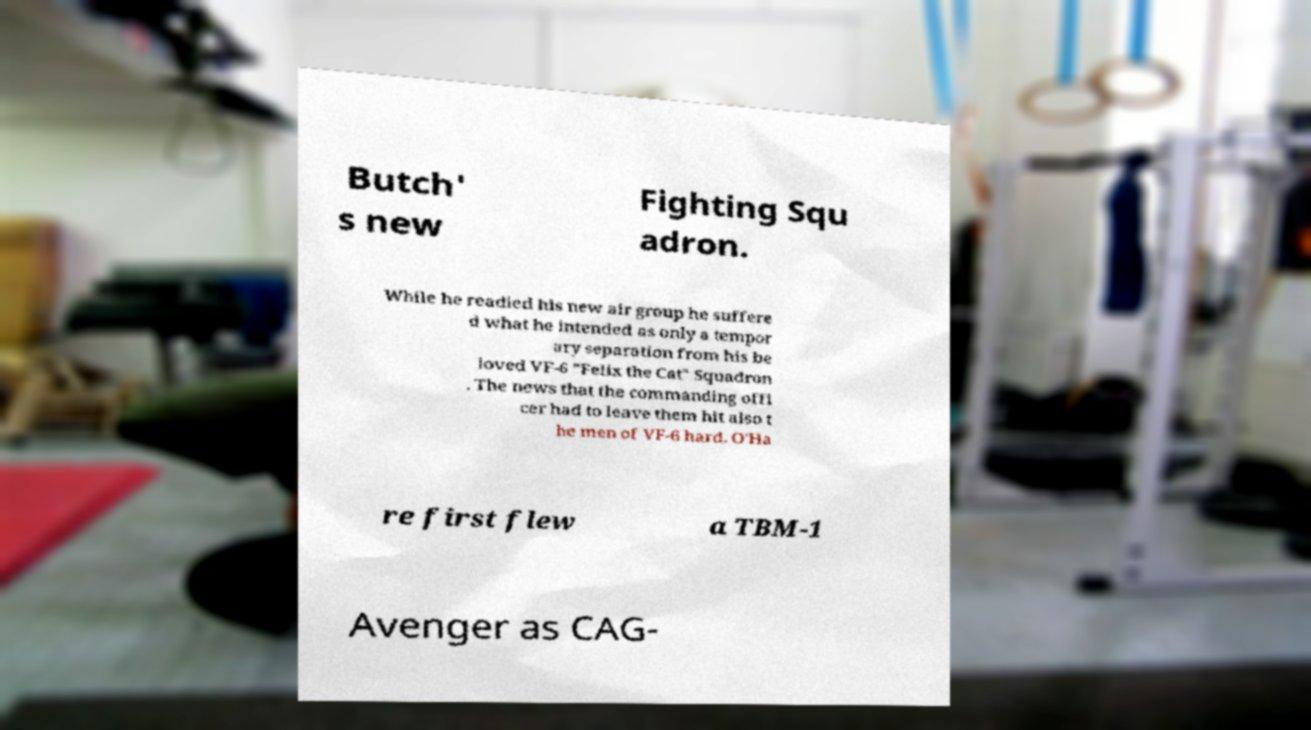Can you read and provide the text displayed in the image?This photo seems to have some interesting text. Can you extract and type it out for me? Butch' s new Fighting Squ adron. While he readied his new air group he suffere d what he intended as only a tempor ary separation from his be loved VF-6 "Felix the Cat" Squadron . The news that the commanding offi cer had to leave them hit also t he men of VF-6 hard. O'Ha re first flew a TBM-1 Avenger as CAG- 